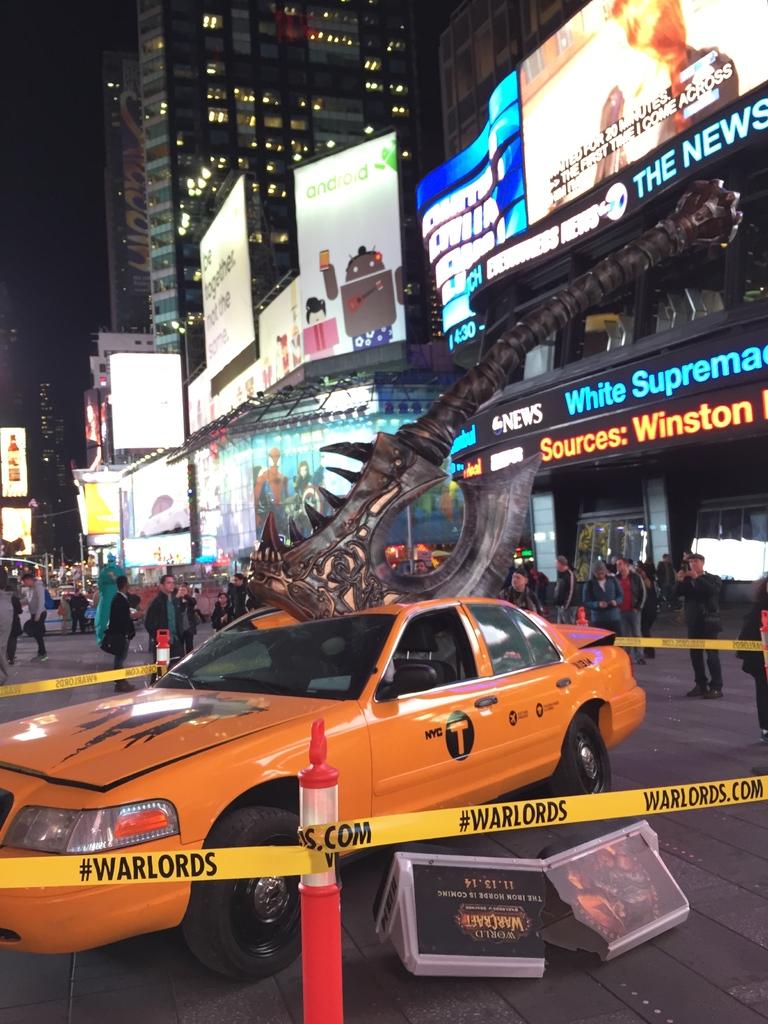What is the caution tape labeled?
Give a very brief answer. #warlords. What´s the city of the taxi?
Provide a short and direct response. Nyc. 